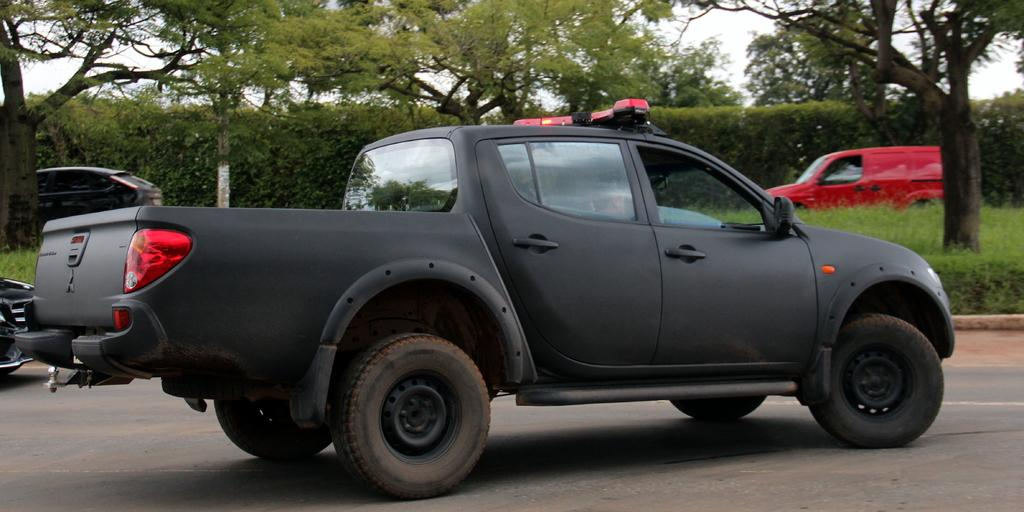What is present on the road in the image? There are vehicles on the road in the image. What type of vegetation can be seen in the image? There are trees and grass visible in the image. What type of vehicles can be seen in the image? There are cars visible in the image. What else is present in the image besides the vehicles and vegetation? There is a group of plants visible in the image. What is visible in the background of the image? The sky is visible in the image, and it appears to be cloudy. What month is it in the image? The month cannot be determined from the image, as there is no information about the date or time of year. Are there any cacti visible in the image? There are no cacti present in the image; only trees and grass are visible. 